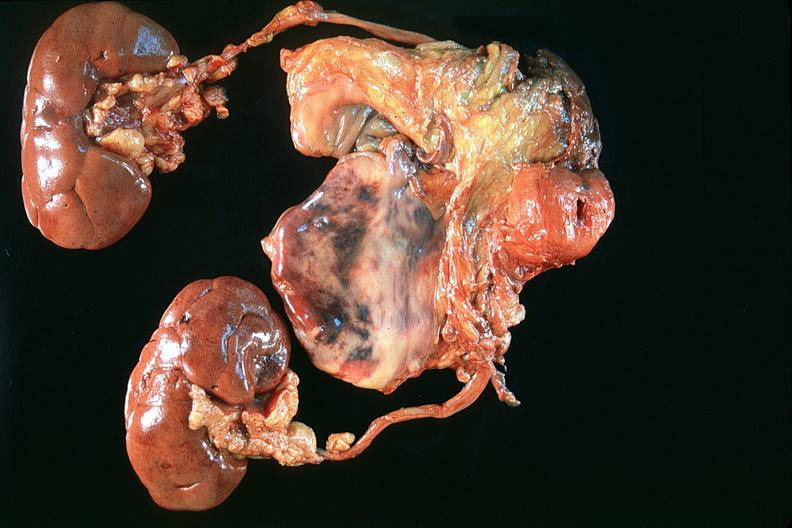what is present?
Answer the question using a single word or phrase. Urinary 